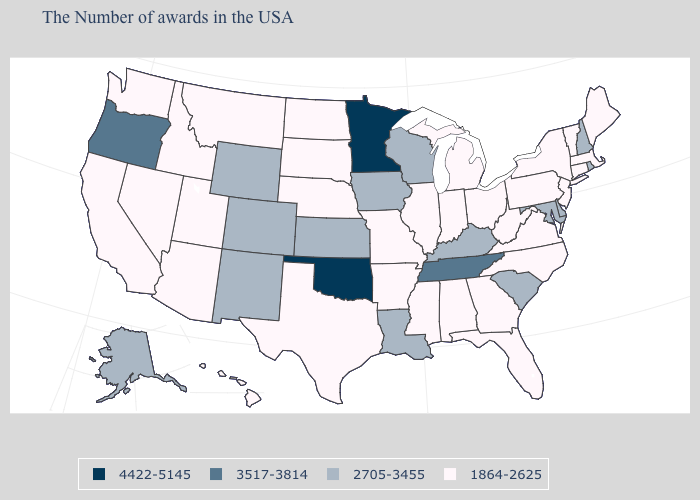What is the lowest value in the MidWest?
Quick response, please. 1864-2625. Name the states that have a value in the range 4422-5145?
Give a very brief answer. Minnesota, Oklahoma. Does the first symbol in the legend represent the smallest category?
Short answer required. No. What is the value of Nevada?
Concise answer only. 1864-2625. Does Delaware have the same value as Nebraska?
Write a very short answer. No. Does Oregon have the highest value in the West?
Keep it brief. Yes. Which states have the lowest value in the USA?
Concise answer only. Maine, Massachusetts, Vermont, Connecticut, New York, New Jersey, Pennsylvania, Virginia, North Carolina, West Virginia, Ohio, Florida, Georgia, Michigan, Indiana, Alabama, Illinois, Mississippi, Missouri, Arkansas, Nebraska, Texas, South Dakota, North Dakota, Utah, Montana, Arizona, Idaho, Nevada, California, Washington, Hawaii. Name the states that have a value in the range 1864-2625?
Concise answer only. Maine, Massachusetts, Vermont, Connecticut, New York, New Jersey, Pennsylvania, Virginia, North Carolina, West Virginia, Ohio, Florida, Georgia, Michigan, Indiana, Alabama, Illinois, Mississippi, Missouri, Arkansas, Nebraska, Texas, South Dakota, North Dakota, Utah, Montana, Arizona, Idaho, Nevada, California, Washington, Hawaii. Does New Mexico have a higher value than Maryland?
Keep it brief. No. What is the highest value in states that border Mississippi?
Answer briefly. 3517-3814. What is the value of North Dakota?
Keep it brief. 1864-2625. What is the value of Connecticut?
Be succinct. 1864-2625. What is the value of Florida?
Answer briefly. 1864-2625. Does Utah have the lowest value in the West?
Concise answer only. Yes. Which states have the highest value in the USA?
Give a very brief answer. Minnesota, Oklahoma. 